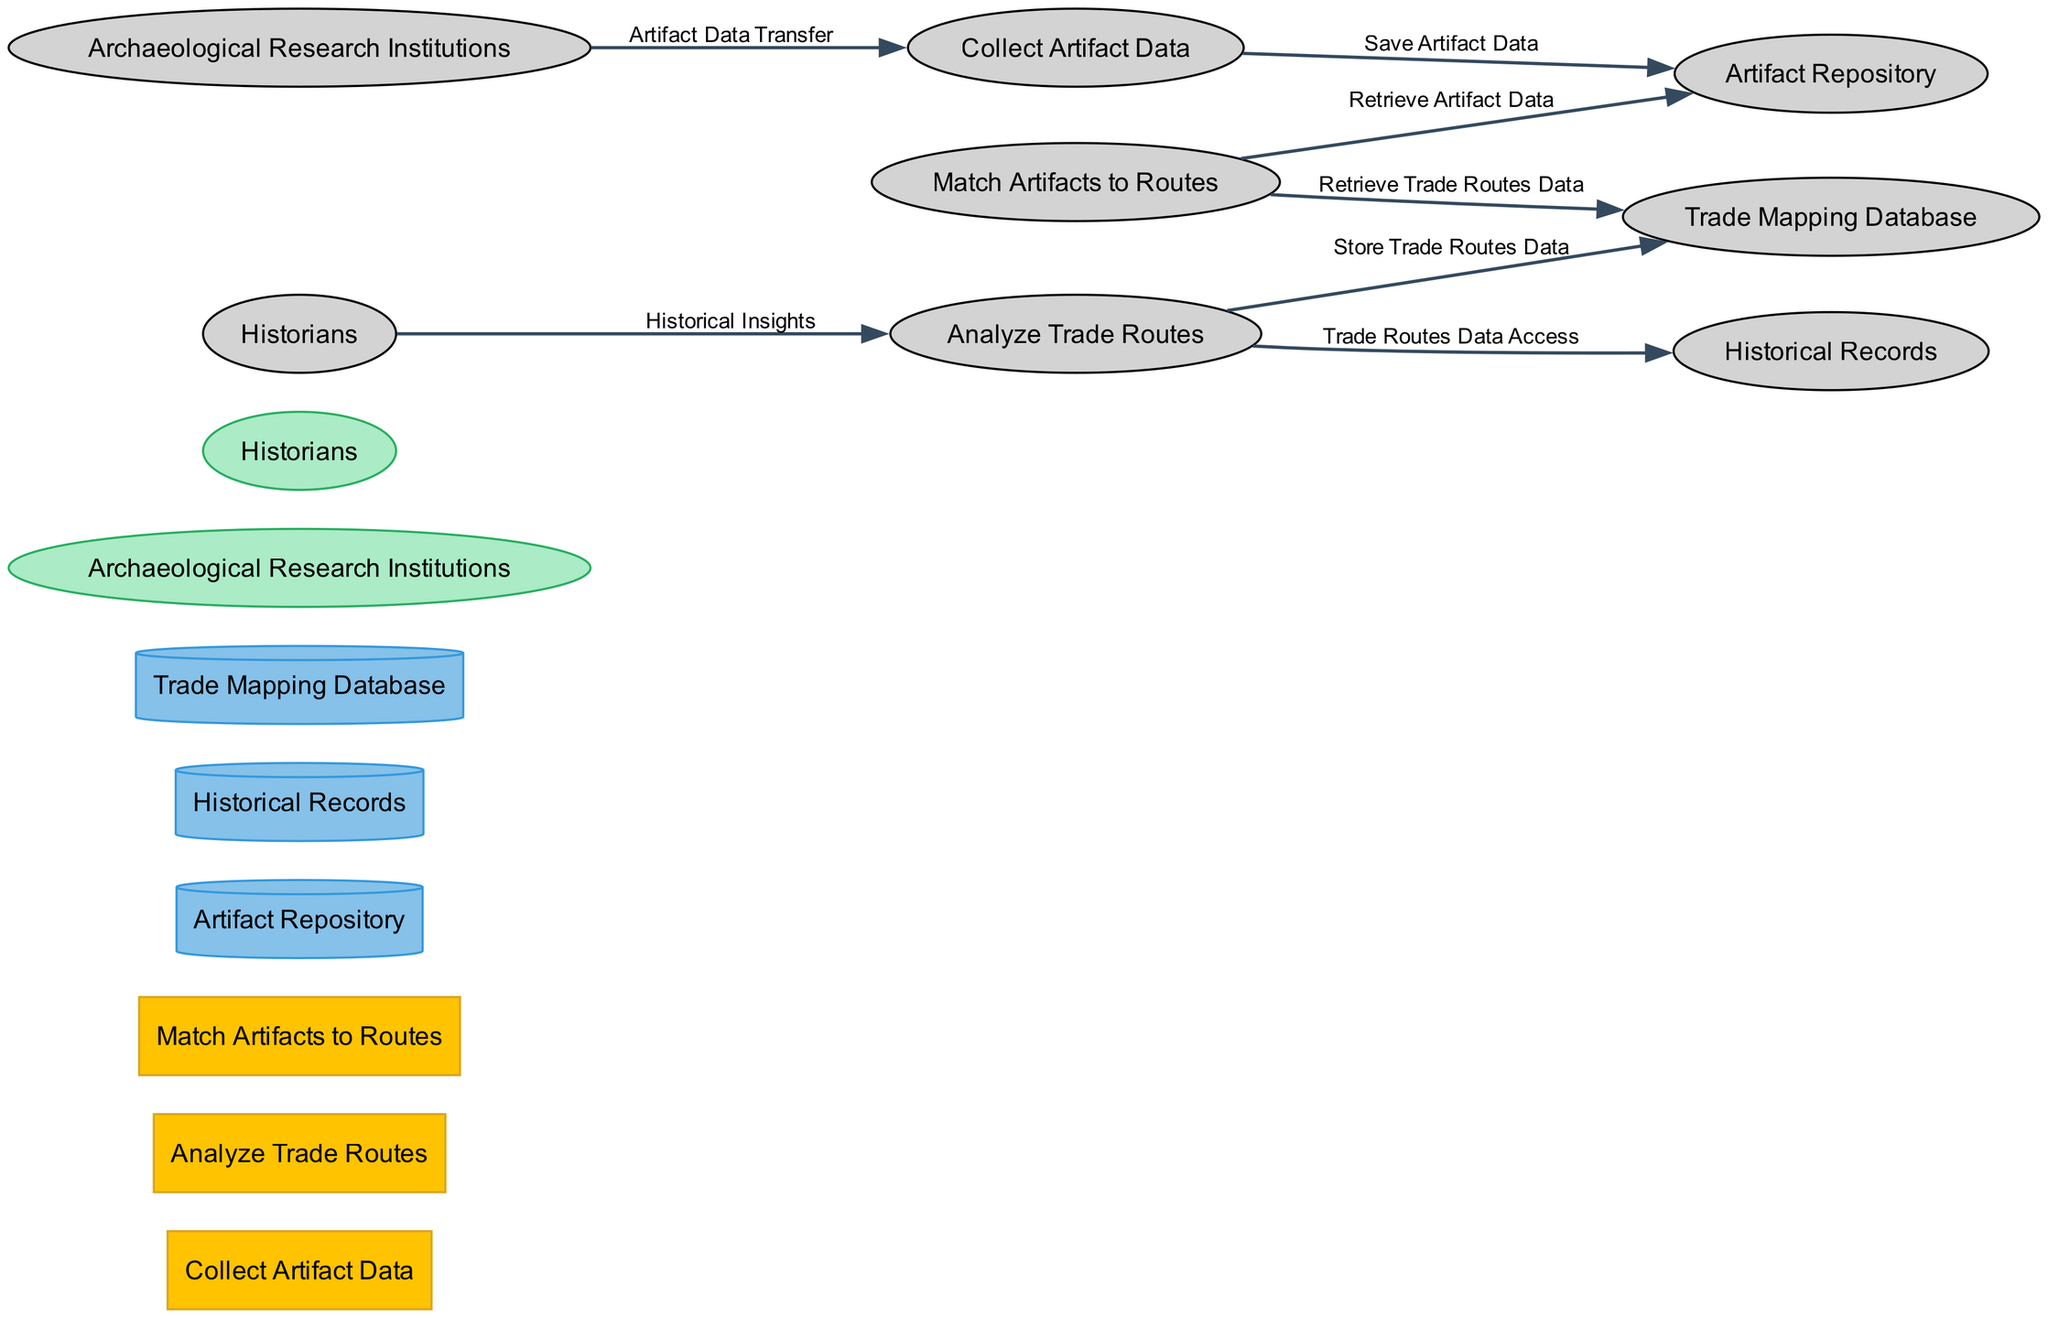What is the name of the process that analyzes trade routes? The process that analyzes trade routes is one of the nodes in the diagram, specifically labeled "Analyze Trade Routes." This can be found in the section for processes, and its description refers directly to studying and mapping trade routes on the Silk Road.
Answer: Analyze Trade Routes How many processes are depicted in the diagram? To find this answer, count the distinct processes listed in the diagram. There are three processes defined in the provided data: "Collect Artifact Data," "Analyze Trade Routes," and "Match Artifacts to Routes." This total is a straightforward enumeration of the entry in the processes section.
Answer: 3 Which external entity provides historical insights? In the diagram, the external entity labeled "Historians" is the one providing historical insights. This is derived from the data flow that shows the connection from Historians to the "Analyze Trade Routes" process, describing the nature of the data flow labeled "Historical Insights."
Answer: Historians What type of data store is "Artifact Repository"? The "Artifact Repository" is categorized as a type of data store in the diagram, and it has the shape of a cylinder, which is standard for data storage nodes. This classification is found within the data stores section of the diagram and its description specifies housing detailed records of artifacts.
Answer: Cylinder How does artifact data transfer to the collection process? The flow of artifact data is depicted by the data flow labeled "Artifact Data Transfer." It originates from the external entity "Archaeological Research Institutions" and is directed toward the "Collect Artifact Data" process. This relationship is shown by an arrow indicating the transfer of information.
Answer: Artifact Data Transfer Which process stores analyzed trade routes data? The process that stores the analyzed trade routes data is labeled "Analyze Trade Routes." It connects to the "Trade Mapping Database" data store through the data flow labeled "Store Trade Routes Data." This step involves the analyzed information being saved into that specific database.
Answer: Analyze Trade Routes What data store contains maps related to trade routes? The data store that contains maps related to trade routes is referred to as the "Trade Mapping Database." This can be identified in the data stores section as it specifically describes the nature of the data it houses, focusing on maps and spatial data linked to Silk Road trade.
Answer: Trade Mapping Database Which process retrieves artifact data for matching with routes? The process designated to retrieve artifact data for matching with routes is "Match Artifacts to Routes." This is evident from the data flow labeled "Retrieve Artifact Data," indicating the action of pulling data from the "Artifact Repository" to facilitate the matching process.
Answer: Match Artifacts to Routes What is the relationship between historians and trade route analysis? Historians contribute to trade route analysis through the data flow labeled "Historical Insights," which connects them to the process "Analyze Trade Routes." This indicates that the insights provided by historians serve as valuable historical context for studying the routes.
Answer: Historical Insights 